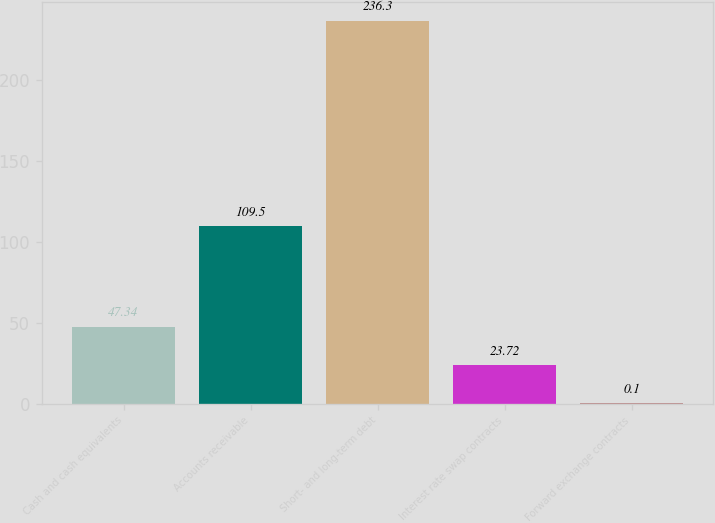Convert chart to OTSL. <chart><loc_0><loc_0><loc_500><loc_500><bar_chart><fcel>Cash and cash equivalents<fcel>Accounts receivable<fcel>Short- and long-term debt<fcel>Interest rate swap contracts<fcel>Forward exchange contracts<nl><fcel>47.34<fcel>109.5<fcel>236.3<fcel>23.72<fcel>0.1<nl></chart> 